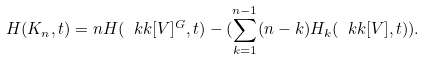Convert formula to latex. <formula><loc_0><loc_0><loc_500><loc_500>H ( K _ { n } , t ) = n H ( \ k k [ V ] ^ { G } , t ) - ( \sum _ { k = 1 } ^ { n - 1 } ( n - k ) H _ { k } ( \ k k [ V ] , t ) ) .</formula> 